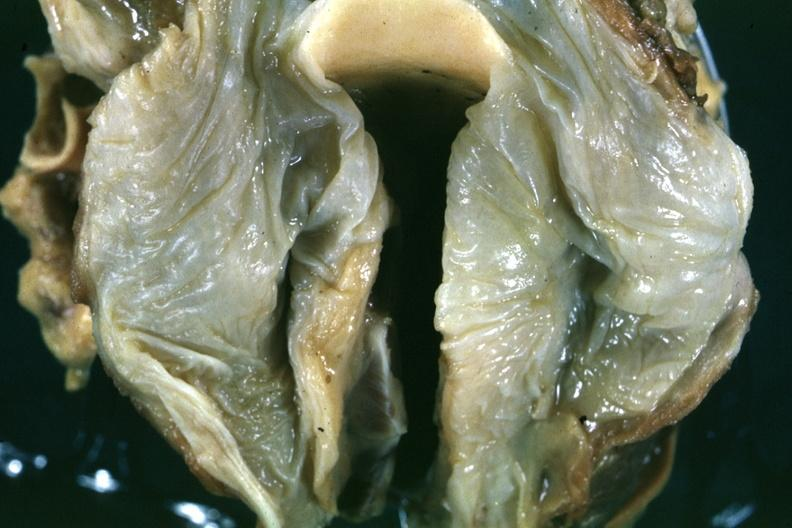what is opened slide is a close-up in natural color of the edematous mucosal membrane?
Answer the question using a single word or phrase. Quite good example hypopharyngeal edema larynx 